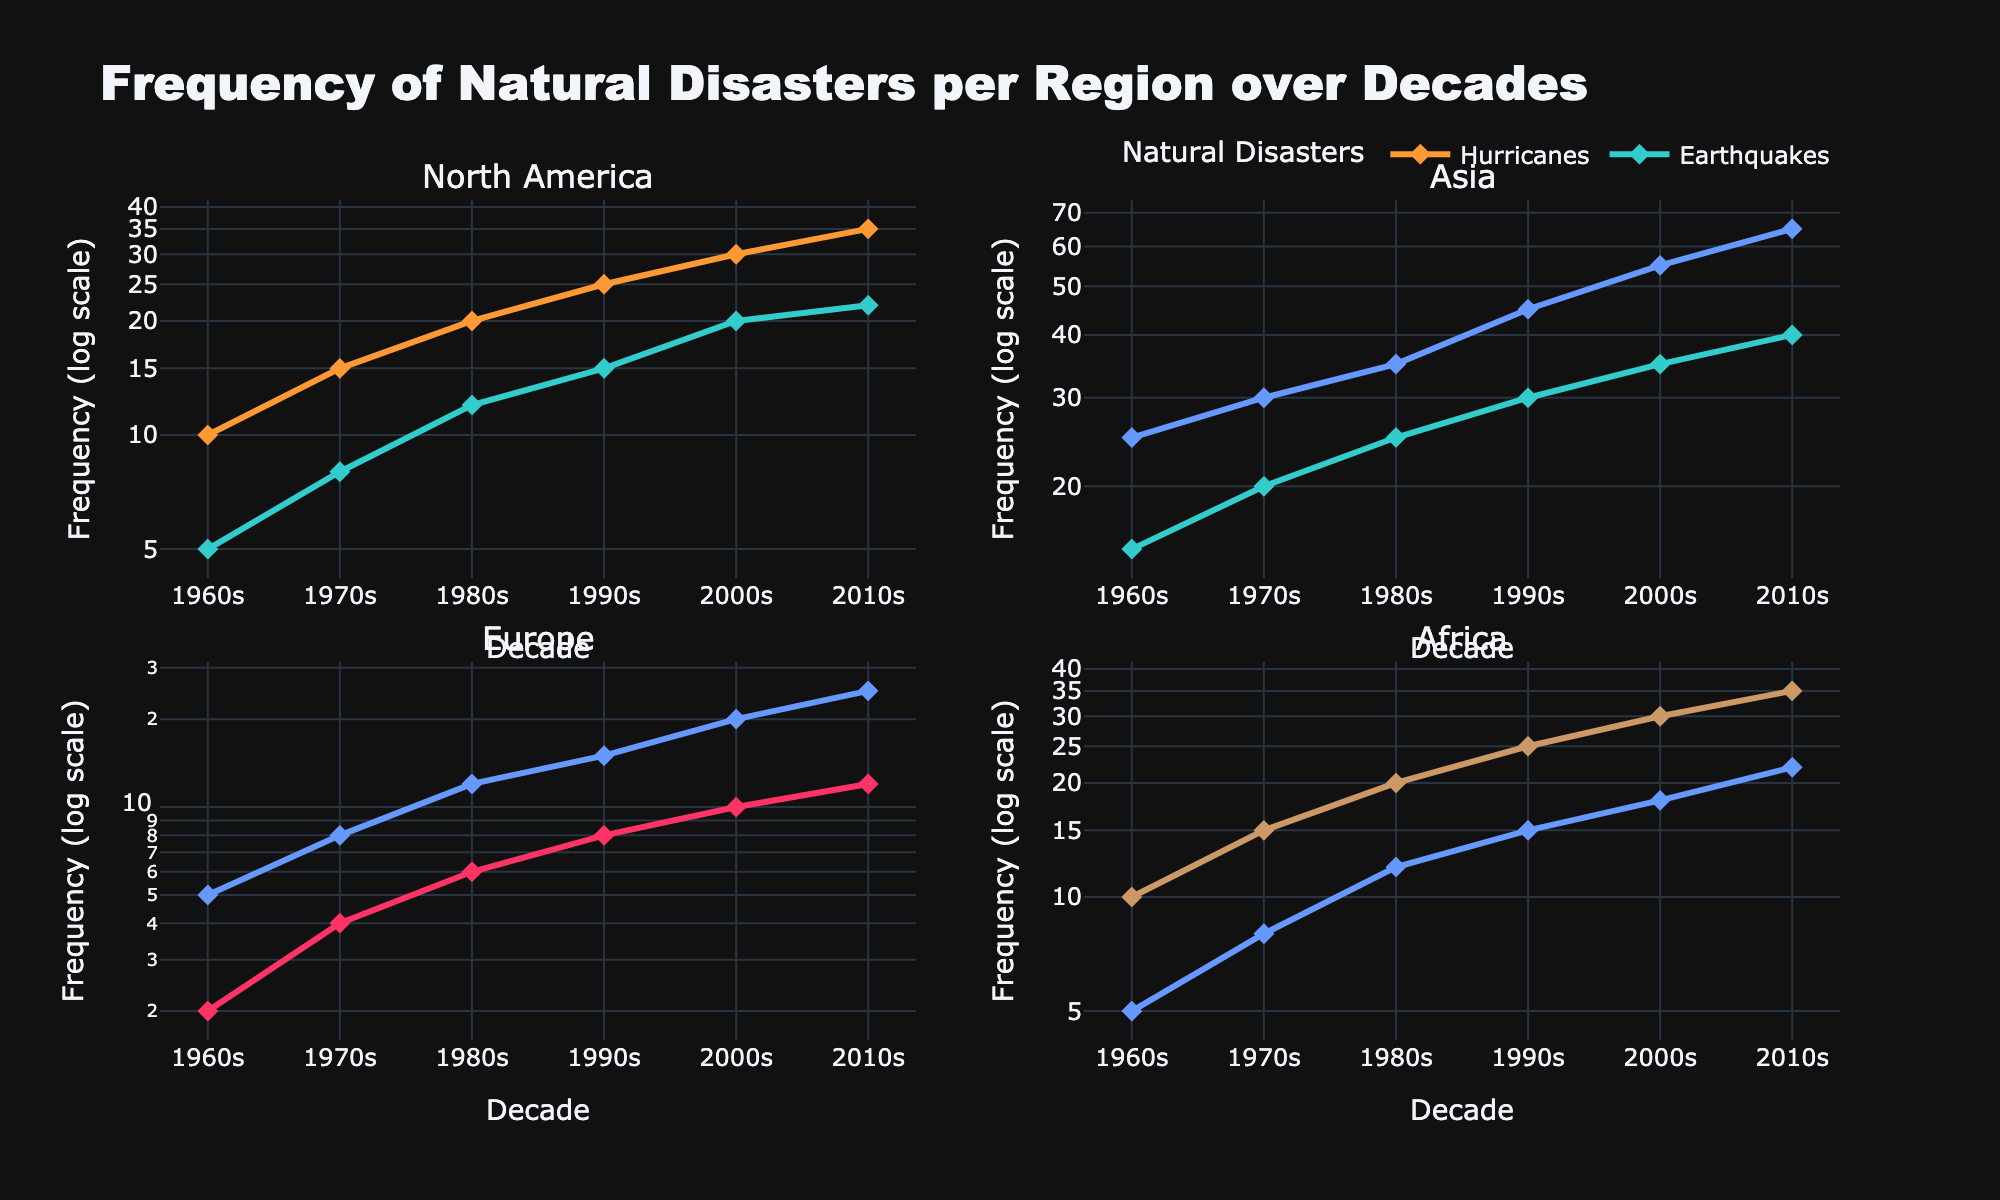What is the title of the figure? The title is usually located at the top of the figure. In this case, it states the overall subject of the figure.
Answer: Frequency of Natural Disasters per Region over Decades Which region had the highest frequency of earthquakes during the 2010s? Look at the subplot titled "North America" and find the data points for the 2010s. Identify the specific natural disaster (earthquakes) and compare frequencies. North America’s earthquake frequency is 22. For the "Asia" and "Africa" subplots, locate the same decade and natural disaster, and compare their frequencies, which are 40 for Asia and 22 for Africa. Asia has the highest frequency of earthquakes in the 2010s.
Answer: Asia How many unique types of natural disasters are depicted in the plots? Each subplot contains distinct lines for different natural disasters. Count the unique legend labels to determine the number of unique types.
Answer: 5 Has the frequency of droughts in Africa increased or decreased from the 1960s to the 2010s? Identify the data points for 'Droughts' in the 'Africa' subplot. Compare the frequencies noted in the 1960s (10) and 2010s (35). The frequency has increased.
Answer: Increased Which natural disaster in North America has shown a constant increase every decade from the 1960s to 2010s? Examine the 'North America' subplot and check the trend for each natural disaster line. Hurricanes show a consistent upward trend in each decade, increasing from 10 to 35.
Answer: Hurricanes Compare the frequency trends of floods in Asia and Europe from the 1970s to the 2010s. Look at the 'Floods' lines in the 'Asia' and 'Europe' subplots. In Asia, the frequency of floods consistently increases (30 to 65). In Europe, the frequency also increases but at a slower rate (8 to 25).
Answer: Both increased, Asia more significantly What is the y-axis of the subplots representing? The y-axis typically indicates the main metric being measured in the plots. Here, it specifies the frequency of natural disasters but on a logarithmic scale.
Answer: Frequency (log scale) Which decade saw the highest frequency of heatwaves in Europe? Find the subplot named 'Europe' and follow the 'Heatwaves' line across the decades. The highest value appears to be in the 2010s (12).
Answer: 2010s In which region and decade did droughts reach a frequency of 35? Look for 'Droughts' across each subplot and decades. In the 'Africa' subplot, the frequency for droughts in the 2010s is 35.
Answer: Africa, 2010s Determine the average frequency of earthquakes in Asia over all the decades shown. Sum the frequencies for earthquakes in the 'Asia' subplot (15+20+25+30+35+40). Then divide the total by the number of decades (6). (15 + 20 + 25 + 30 + 35 + 40) = 165. So, the average is 165 / 6.
Answer: 27.5 